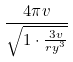Convert formula to latex. <formula><loc_0><loc_0><loc_500><loc_500>\frac { 4 \pi v } { \sqrt { 1 \cdot \frac { 3 v } { r y ^ { 3 } } } }</formula> 